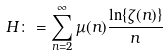Convert formula to latex. <formula><loc_0><loc_0><loc_500><loc_500>H \colon = \sum _ { n = 2 } ^ { \infty } \mu ( n ) \frac { \ln \{ \zeta ( n ) \} } { n }</formula> 